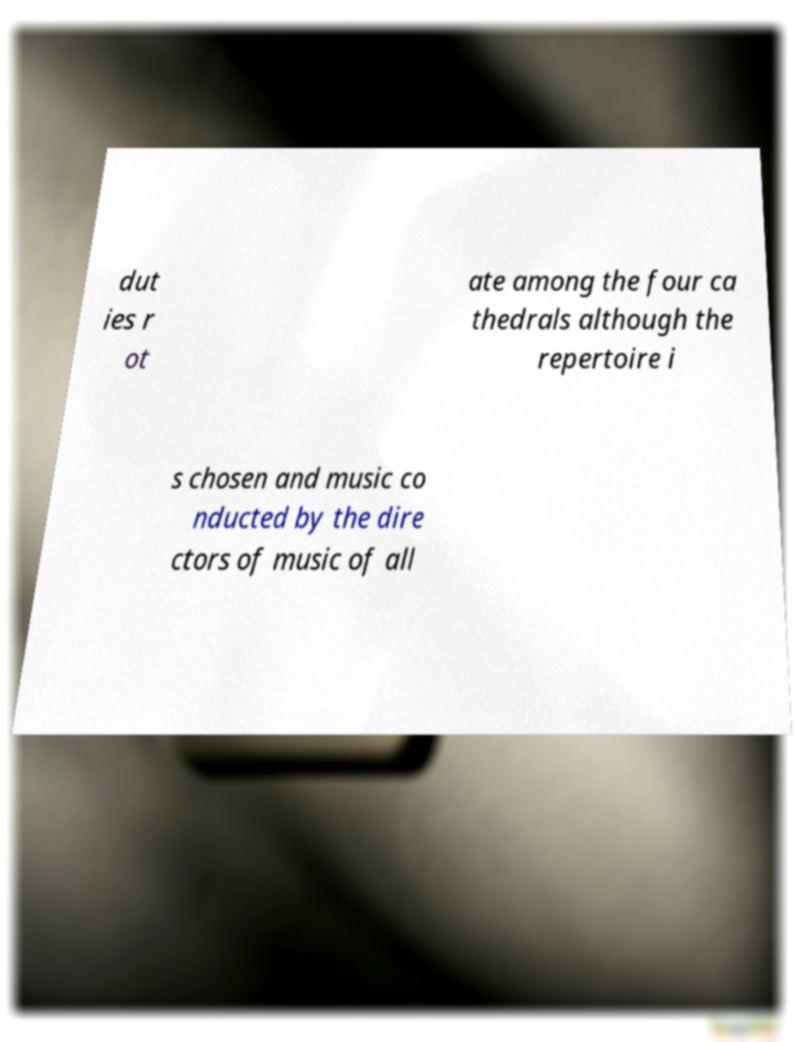Can you accurately transcribe the text from the provided image for me? dut ies r ot ate among the four ca thedrals although the repertoire i s chosen and music co nducted by the dire ctors of music of all 